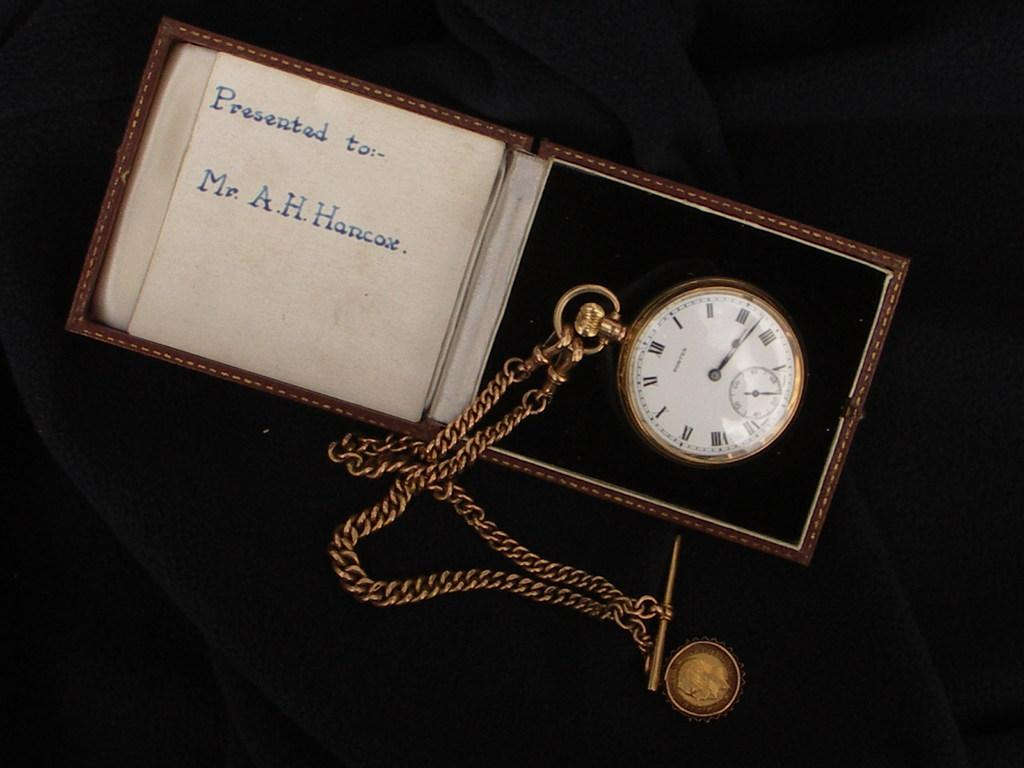<image>
Summarize the visual content of the image. A pocket watch that is presented to Mr. A.H. Hancox. 